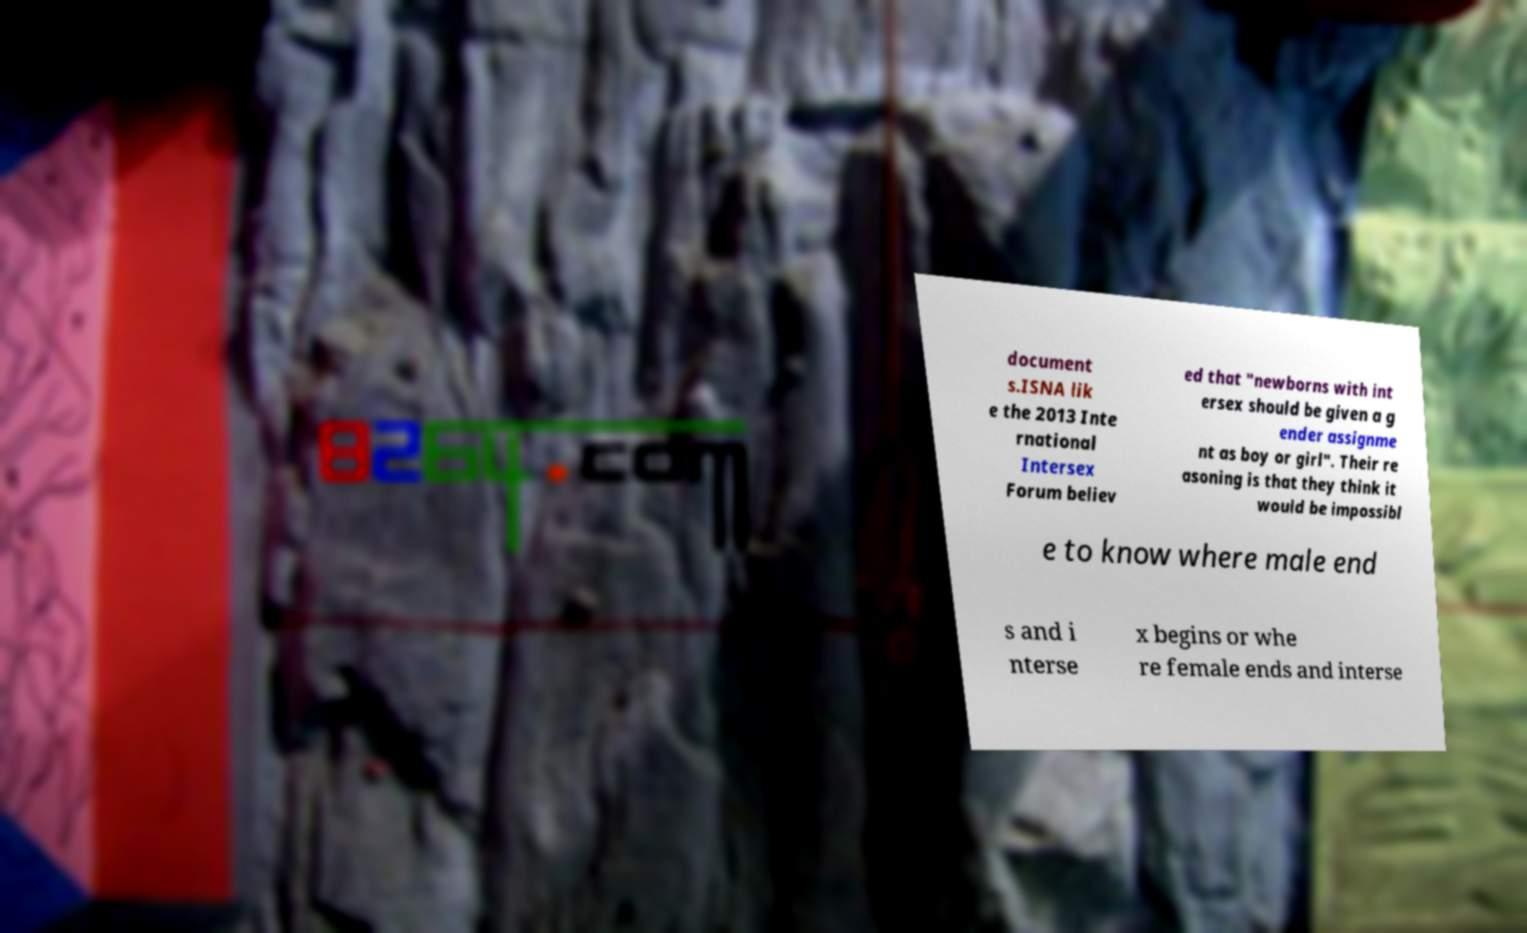Please identify and transcribe the text found in this image. document s.ISNA lik e the 2013 Inte rnational Intersex Forum believ ed that "newborns with int ersex should be given a g ender assignme nt as boy or girl". Their re asoning is that they think it would be impossibl e to know where male end s and i nterse x begins or whe re female ends and interse 